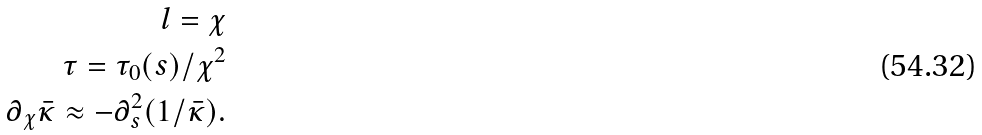<formula> <loc_0><loc_0><loc_500><loc_500>l = \chi \\ \tau = \tau _ { 0 } ( s ) / \chi ^ { 2 } \\ \partial _ { \chi } \bar { \kappa } \approx - \partial _ { s } ^ { 2 } ( 1 / \bar { \kappa } ) .</formula> 